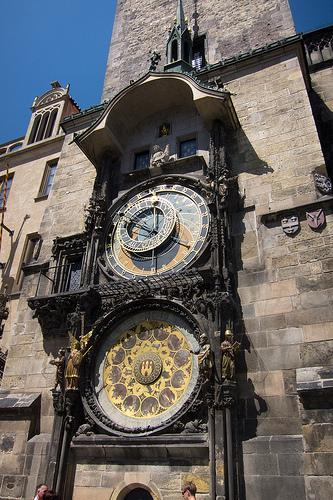Question: what time is it on this clock?
Choices:
A. 8:27.
B. About 5:30.
C. 7:32.
D. 6:21.
Answer with the letter. Answer: B Question: how is the sky?
Choices:
A. Clear.
B. Sunny.
C. Rainy.
D. Stormy.
Answer with the letter. Answer: A Question: what are at the bottom of the picture?
Choices:
A. The feet of people.
B. The heads of two people.
C. The hands of people.
D. The torso of people.
Answer with the letter. Answer: B Question: what is the building made of?
Choices:
A. Glass.
B. Plastic.
C. Stone.
D. Wood.
Answer with the letter. Answer: C Question: what color are the decorations on this clock face?
Choices:
A. Black.
B. White.
C. Green.
D. Gold.
Answer with the letter. Answer: D Question: when was this picture likely taken?
Choices:
A. Night.
B. In the afternoon.
C. Morning.
D. Dusk.
Answer with the letter. Answer: B 